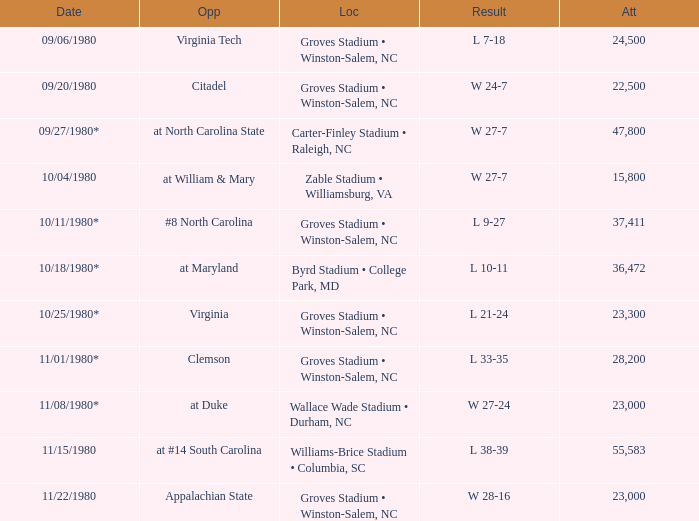How many people attended when Wake Forest played Virginia Tech? 24500.0. 